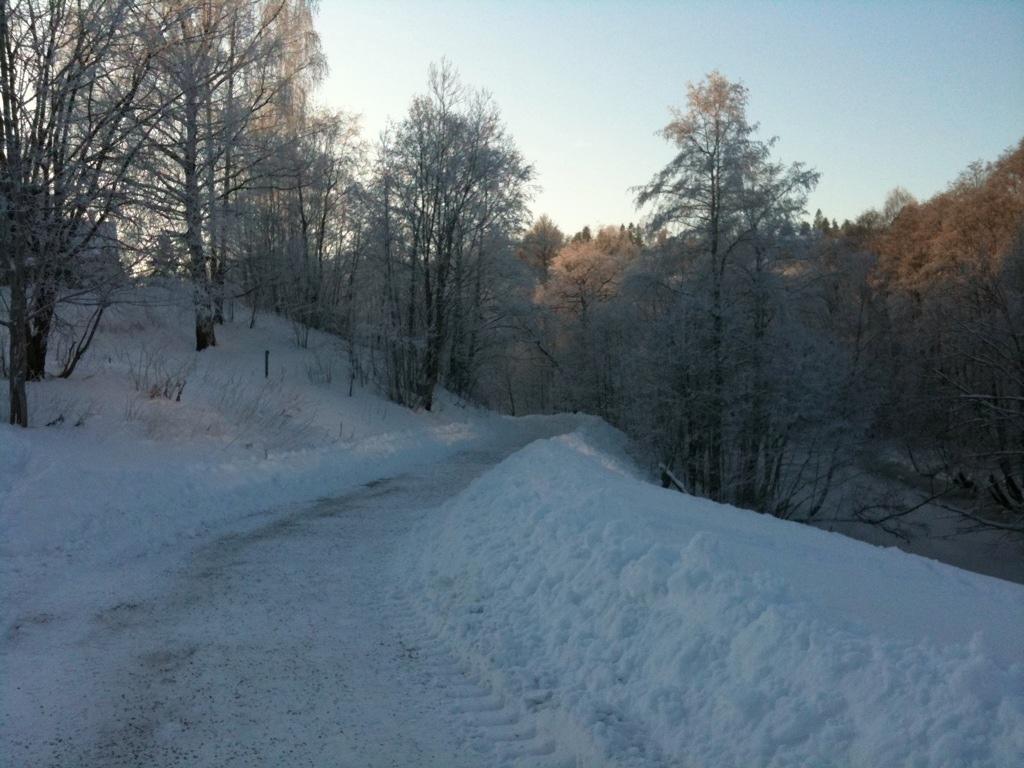In one or two sentences, can you explain what this image depicts? In this image I can see the road, some snow on both sides of the road and few trees and snow on the trees. In the background I can see few trees which are green in color and the sky. 